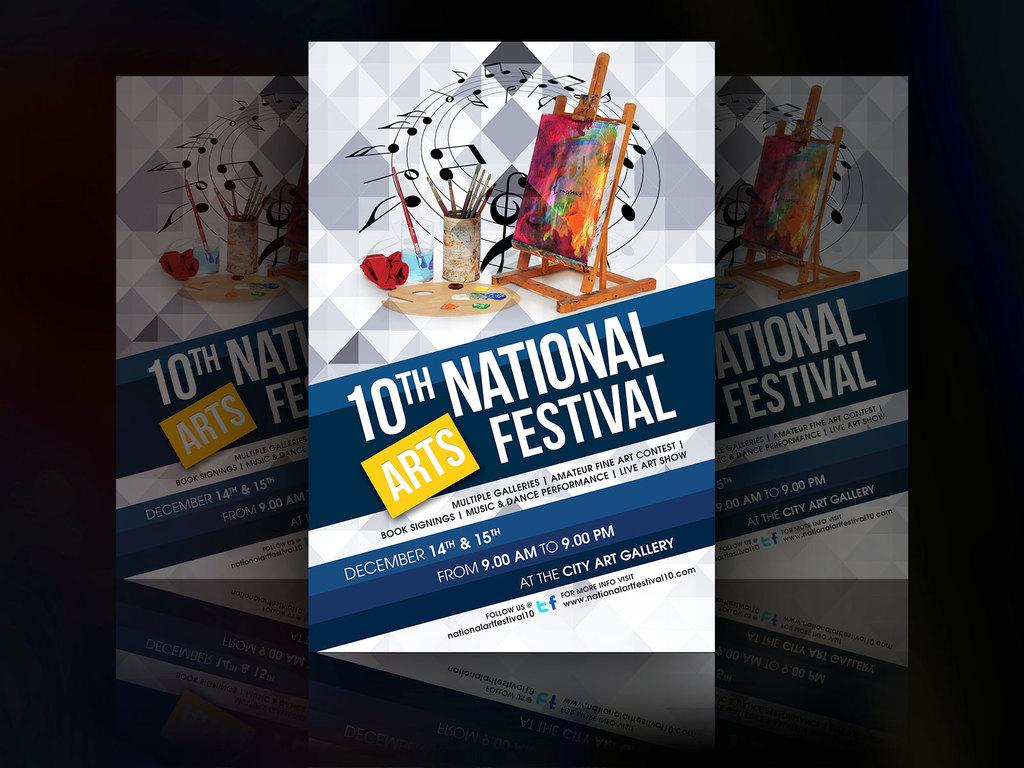<image>
Summarize the visual content of the image. The poster advertising the 10th National Arts Festival. 